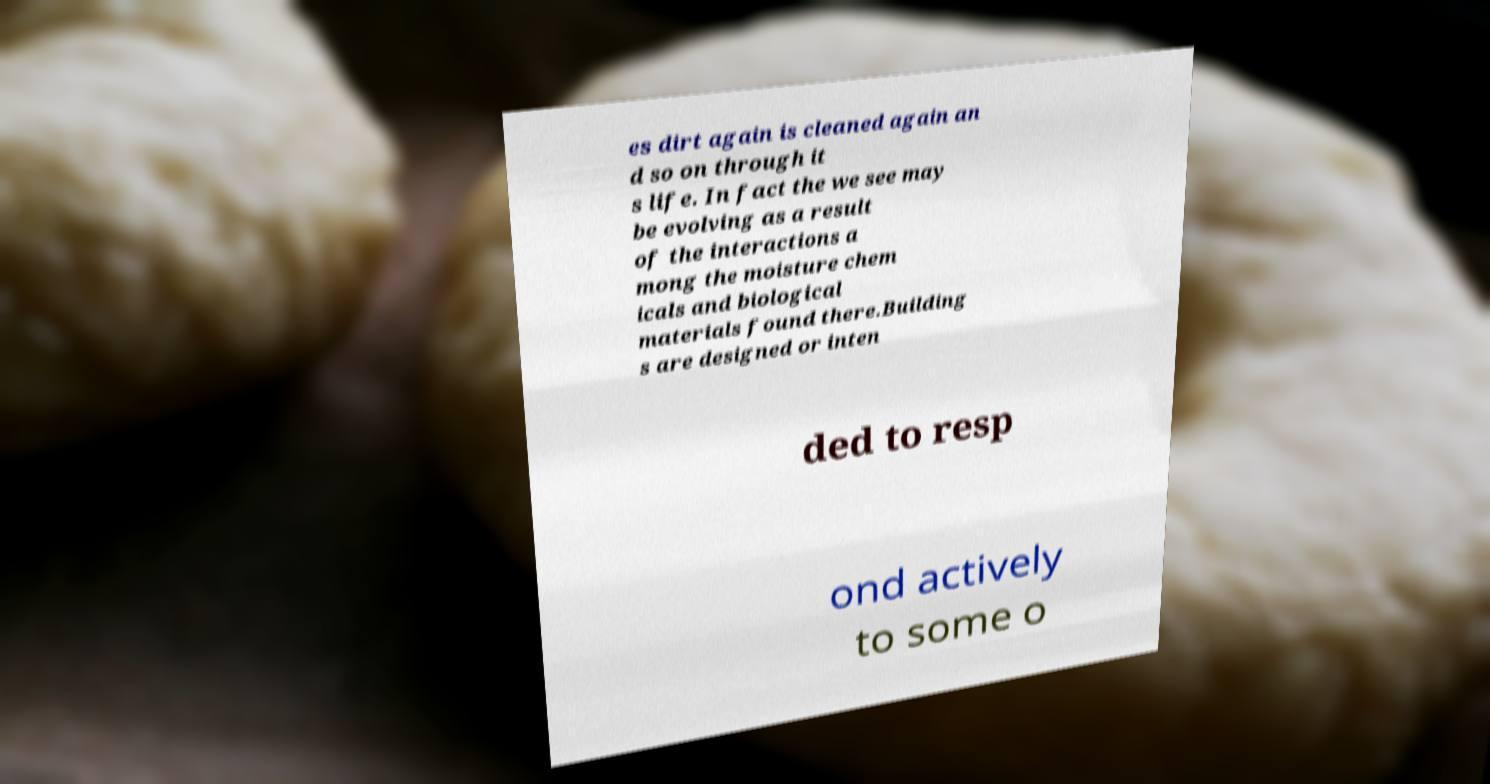I need the written content from this picture converted into text. Can you do that? es dirt again is cleaned again an d so on through it s life. In fact the we see may be evolving as a result of the interactions a mong the moisture chem icals and biological materials found there.Building s are designed or inten ded to resp ond actively to some o 